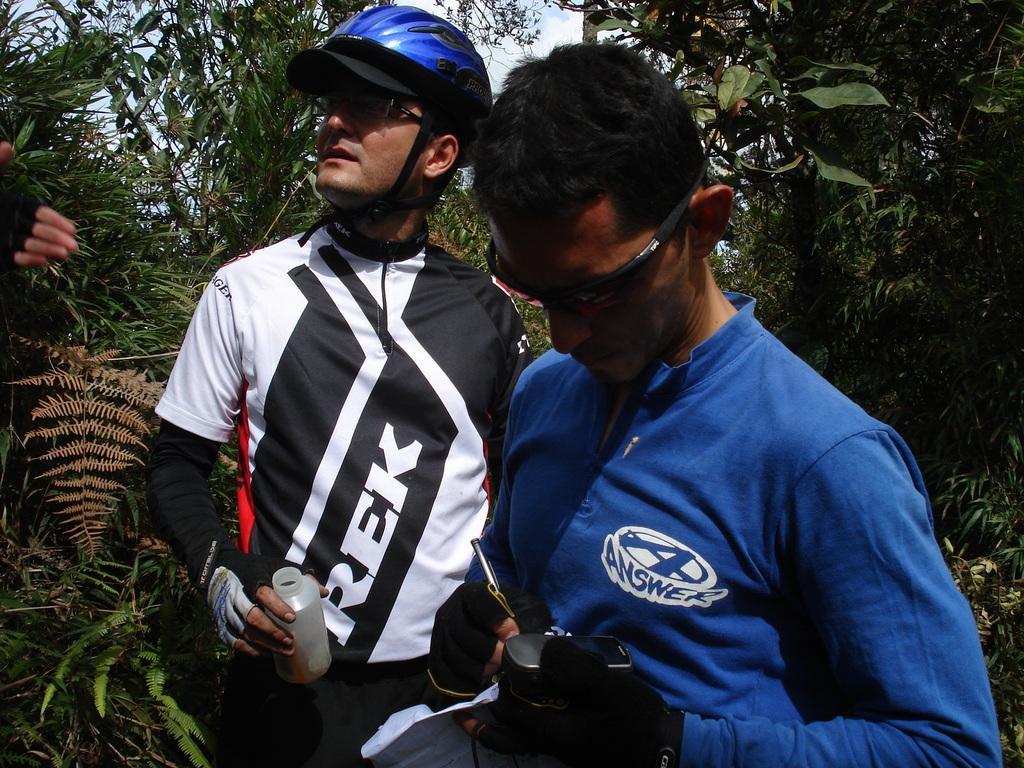Describe this image in one or two sentences. In this image we can see two persons wearing dress are standing. One person is wearing goggles and one person is wearing a helmet, spectacles and holding a bottle in his hand. In the background, we can see a group of trees. 